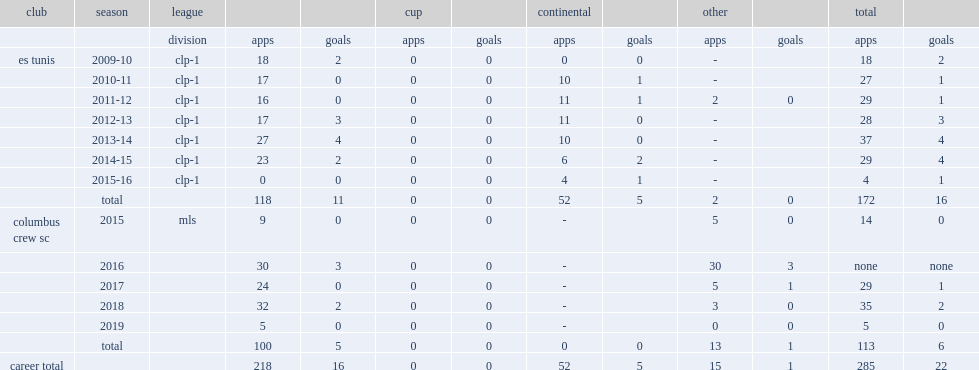How many goals did harrison score for esperance totally? 16.0. 